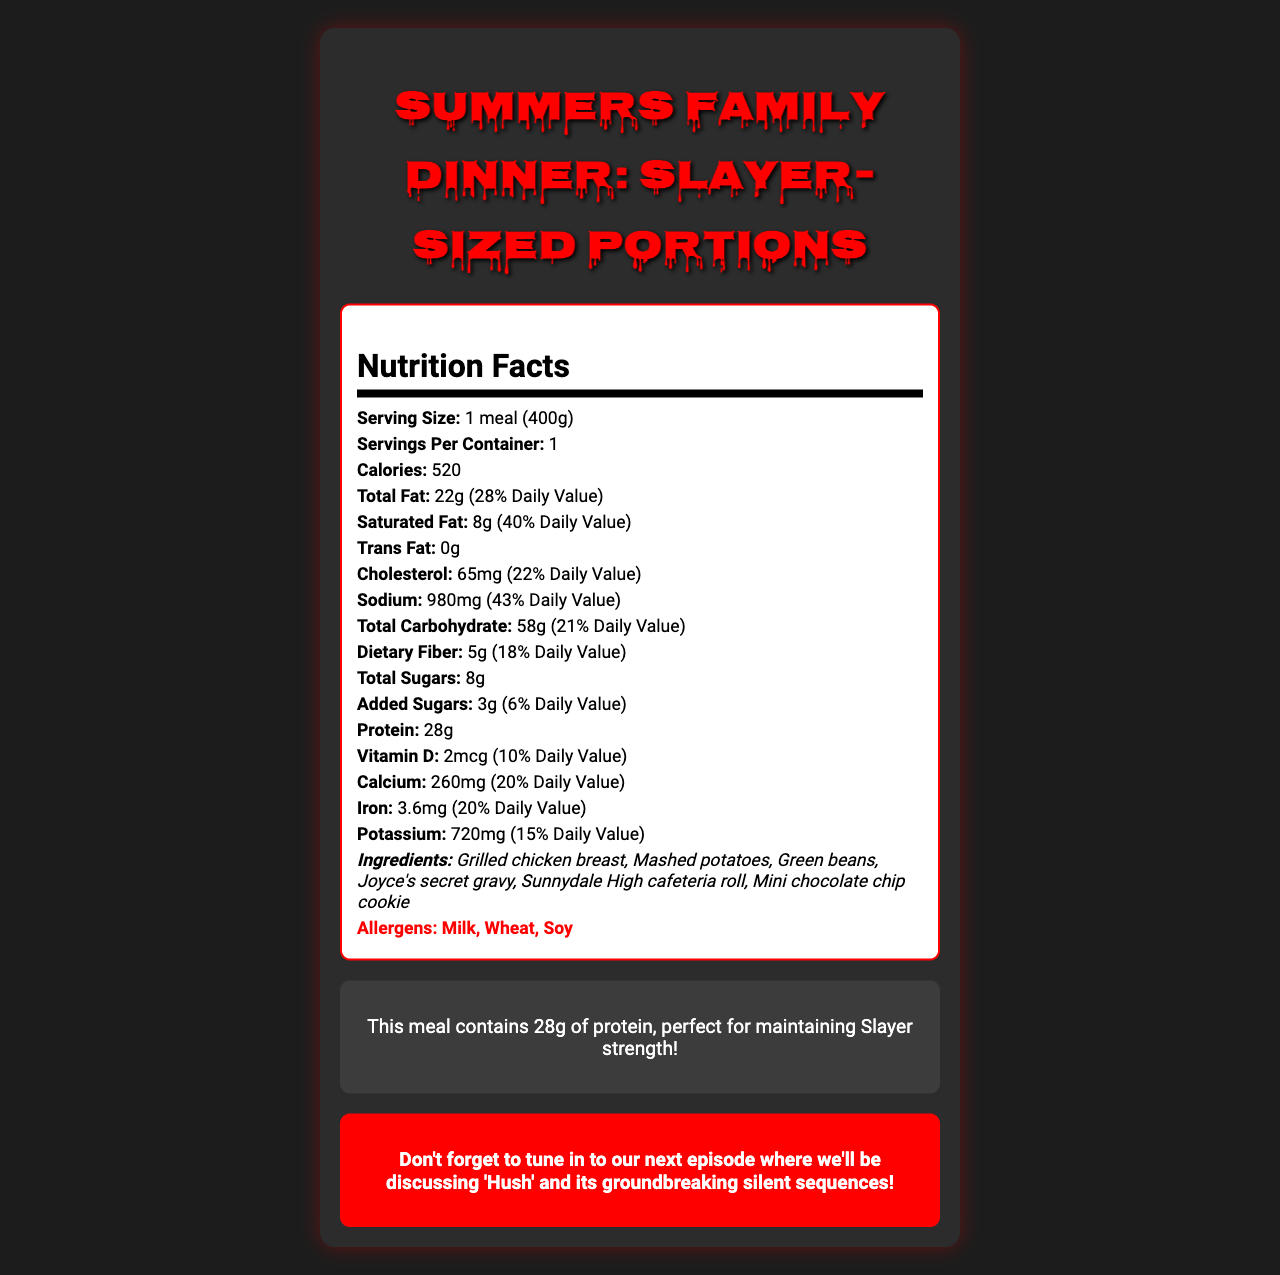what are the allergens listed in the "Summers Family Dinner: Slayer-Sized Portions"? The document lists Milk, Wheat, and Soy as the allergens.
Answer: Milk, Wheat, Soy how many grams of protein are in one serving of the "Summers Family Dinner"? The document specifies that one meal contains 28 grams of protein.
Answer: 28g what is the serving size for the "Summers Family Dinner"? The serving size is listed as "1 meal (400g)" in the document.
Answer: 1 meal (400g) how many calories are in one serving of the "Summers Family Dinner"? The document states that there are 520 calories in one serving.
Answer: 520 what is the percentage daily value of sodium in the meal? The document indicates that the sodium content is 980mg, which is 43% of the daily value.
Answer: 43% which ingredient is featured in the "Joyce's secret gravy"? A. Green beans B. Mashed potatoes C. Grilled chicken breast D. Sunnydale High cafeteria roll The ingredients listed include "Grilled chicken breast, Mashed potatoes, Green beans, Joyce's secret gravy, Sunnydale High cafeteria roll, Mini chocolate chip cookie," making Grilled chicken breast the most likely featured ingredient in the gravy.
Answer: C. Grilled chicken breast what is the trivia fact related to protein in the meal? A. It contains 30g of protein B. It's good for vampire strength C. It helps maintain Slayer strength D. It's high in carbs The document mentions that the meal contains 28g of protein, perfect for maintaining Slayer strength.
Answer: C. It helps maintain Slayer strength is there any trans fat in the "Summers Family Dinner"? The document states that the trans fat amount is 0g.
Answer: No summarize the main idea of the "Summers Family Dinner" nutrition document. The document provides comprehensive nutritional information about the meal, including calories, macronutrients, micronutrients, ingredients, and allergens. Additionally, it encapsulates a Buffy-themed trivia and a podcast promotion.
Answer: The "Summers Family Dinner: Slayer-Sized Portions" is a nutritious frozen TV meal that contains one serving per container, providing 520 calories. It includes significant amounts of protein, total fat, carbohydrates, vitamins, and minerals, with detailed daily values for each. Moreover, it lists ingredients and allergens, offers a Buffy-themed trivia fact, and promotes a related podcast episode. what are the ingredients in the "Summers Family Dinner"? The document lists these ingredients explicitly.
Answer: Grilled chicken breast, Mashed potatoes, Green beans, Joyce's secret gravy, Sunnydale High cafeteria roll, Mini chocolate chip cookie what is the total amount of dietary fiber in the meal, and its daily value percentage? The document specifies that the meal contains 5 grams of dietary fiber, which is 18% of the daily value.
Answer: 5g, 18% does the meal contain any added sugars? The document lists that the meal contains 3 grams of added sugars, which is 6% of the daily value.
Answer: Yes what is the vitamin D content and its daily value percentage? The document states that the vitamin D content is 2mcg, which accounts for 10% of the daily value.
Answer: 2mcg, 10% can the meal be considered low-sodium? The sodium content is 980mg, which is 43% of the daily value, making it relatively high in sodium.
Answer: No what is the daily value percentage of calcium in the meal? The document indicates that the calcium content is 260mg, which corresponds to 20% of the daily value.
Answer: 20% when will the next podcast episode be aired, and what will it discuss? The document promotes the podcast but does not specify the airing date. It only mentions that the next episode will discuss "Hush" and its groundbreaking silent sequences.
Answer: Not enough information 